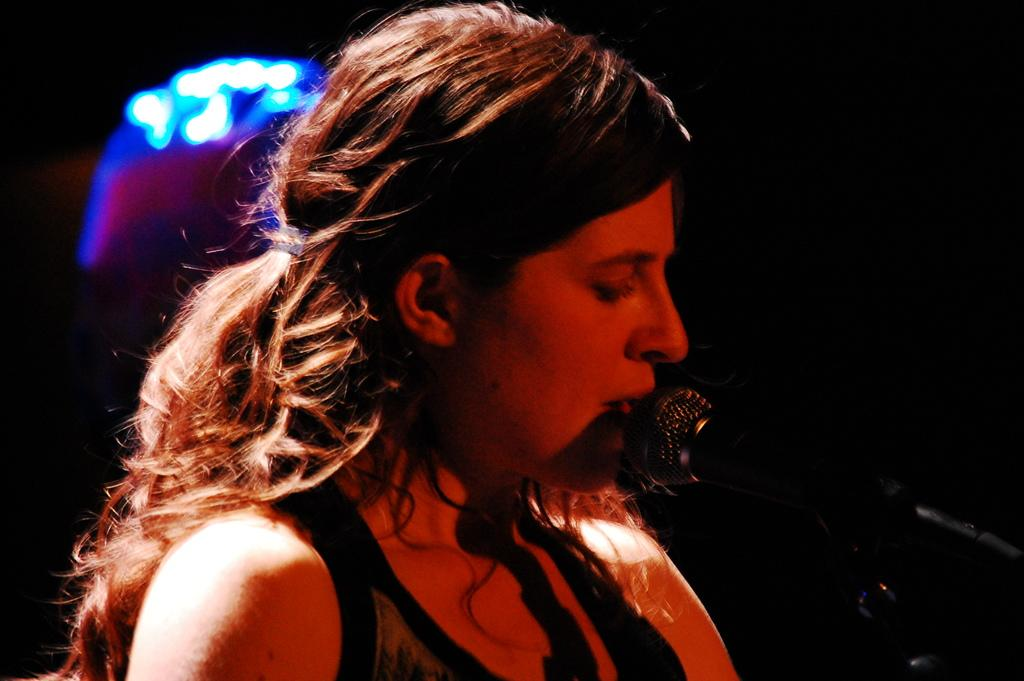Who is the main subject in the image? There is a woman in the image. What is the woman doing in the image? The woman is singing. What object is in front of the woman? There is a microphone in front of the woman. What can be observed about the background of the image? The background of the image is dark. What else can be seen in the image besides the woman and the microphone? There are lights visible in the image. What type of roof can be seen in the image? There is no roof visible in the image. What kind of oil is being used by the woman while singing? The woman is not using any oil while singing; she is using a microphone. 